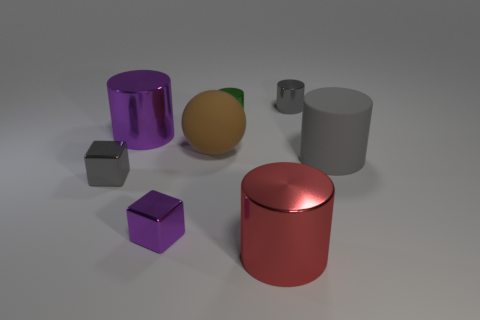How many gray objects are either large matte things or metallic blocks?
Your response must be concise. 2. Are there fewer gray rubber cylinders that are in front of the small gray cube than tiny rubber spheres?
Ensure brevity in your answer.  No. There is a large metallic cylinder that is behind the tiny gray metallic cube; what number of big objects are behind it?
Make the answer very short. 0. What number of other things are the same size as the red metallic object?
Provide a short and direct response. 3. How many objects are either big red metal objects or metallic cylinders to the left of the red object?
Offer a terse response. 3. Are there fewer large red cylinders than big blue metallic things?
Your answer should be very brief. No. What is the color of the cylinder right of the small gray thing that is behind the large purple thing?
Give a very brief answer. Gray. There is a large gray object that is the same shape as the red metallic object; what is its material?
Your response must be concise. Rubber. What number of rubber objects are either big purple objects or large red objects?
Your answer should be compact. 0. Does the tiny gray object on the right side of the tiny gray shiny cube have the same material as the big cylinder in front of the gray block?
Keep it short and to the point. Yes. 